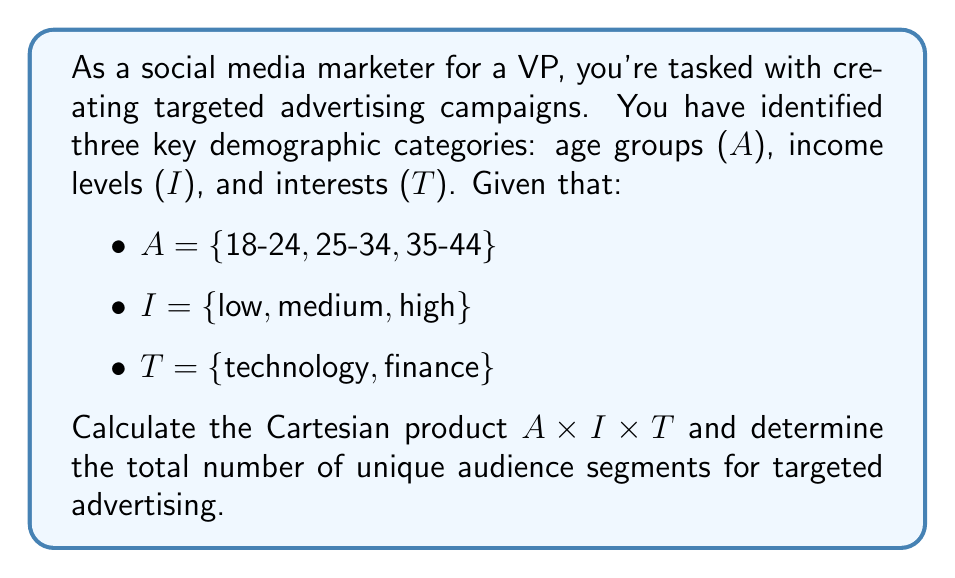Provide a solution to this math problem. To solve this problem, we need to understand the Cartesian product and how it applies to creating audience segments for targeted advertising.

1. The Cartesian product of sets A, I, and T is denoted as $A \times I \times T$. It consists of all possible ordered triples (a, i, t) where $a \in A$, $i \in I$, and $t \in T$.

2. Let's break down the given sets:
   - A has 3 elements: |A| = 3
   - I has 3 elements: |I| = 3
   - T has 2 elements: |T| = 2

3. The Cartesian product $A \times I \times T$ will contain all possible combinations of these elements. Each combination represents a unique audience segment.

4. To calculate the number of elements in the Cartesian product, we multiply the number of elements in each set:

   $|A \times I \times T| = |A| \times |I| \times |T| = 3 \times 3 \times 2 = 18$

5. To list all elements of $A \times I \times T$:

   A × I × T = {
   (18-24, low, technology), (18-24, low, finance),
   (18-24, medium, technology), (18-24, medium, finance),
   (18-24, high, technology), (18-24, high, finance),
   (25-34, low, technology), (25-34, low, finance),
   (25-34, medium, technology), (25-34, medium, finance),
   (25-34, high, technology), (25-34, high, finance),
   (35-44, low, technology), (35-44, low, finance),
   (35-44, medium, technology), (35-44, medium, finance),
   (35-44, high, technology), (35-44, high, finance)
   }

Each of these ordered triples represents a unique audience segment for targeted advertising, combining age group, income level, and interest.
Answer: The Cartesian product $A \times I \times T$ results in 18 unique audience segments for targeted advertising. 